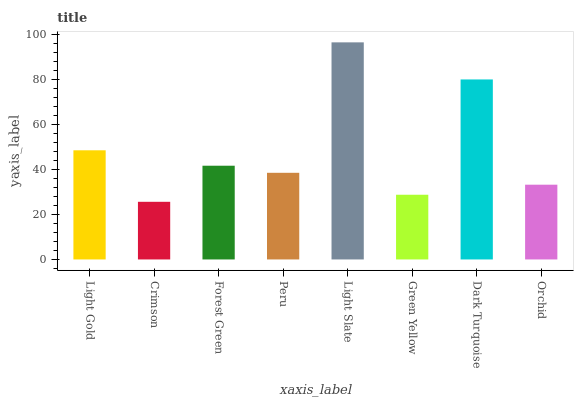Is Forest Green the minimum?
Answer yes or no. No. Is Forest Green the maximum?
Answer yes or no. No. Is Forest Green greater than Crimson?
Answer yes or no. Yes. Is Crimson less than Forest Green?
Answer yes or no. Yes. Is Crimson greater than Forest Green?
Answer yes or no. No. Is Forest Green less than Crimson?
Answer yes or no. No. Is Forest Green the high median?
Answer yes or no. Yes. Is Peru the low median?
Answer yes or no. Yes. Is Green Yellow the high median?
Answer yes or no. No. Is Green Yellow the low median?
Answer yes or no. No. 